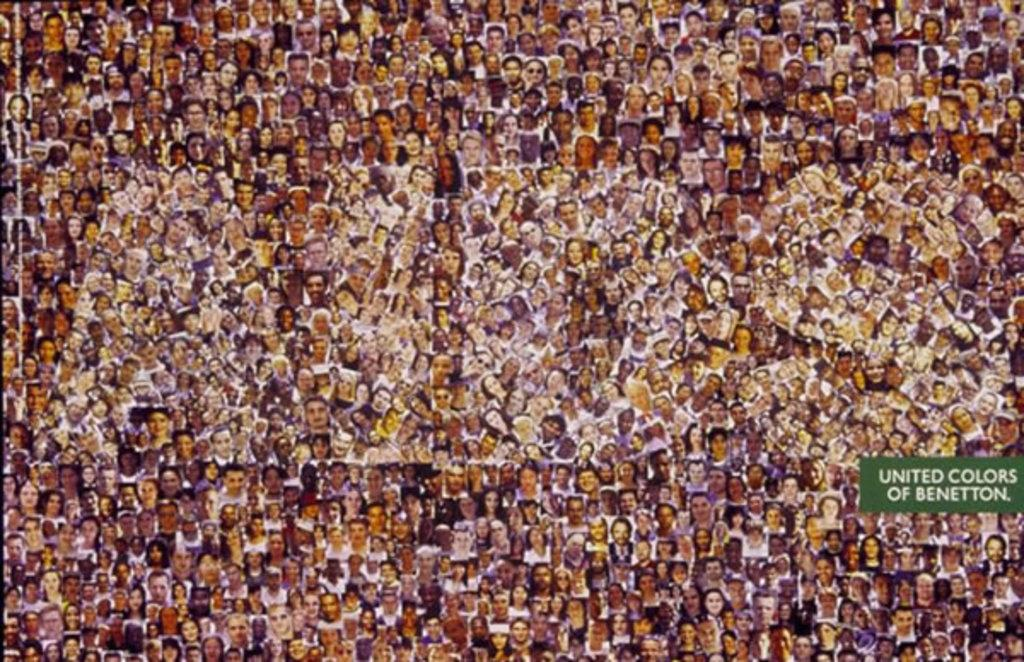What is the main subject of the image? The image contains a collage of many people. Can you describe any specific elements on the right side of the image? There is a green tag on the right side of the image. What is written on the green tag? The green tag has the text "united colors of benetton" written on it. Is there any other text or symbol present in the image? Yes, there is a watermark "aids" in the image. How many inches is the crown worn by the person in the image? There is no crown present in the image, so it is not possible to determine its size. 